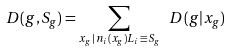<formula> <loc_0><loc_0><loc_500><loc_500>D ( g , S _ { g } ) = \sum _ { x _ { g } \, | \, n _ { i } ( x _ { g } ) L _ { i } \, \equiv \, S _ { g } } \ D ( g | x _ { g } )</formula> 